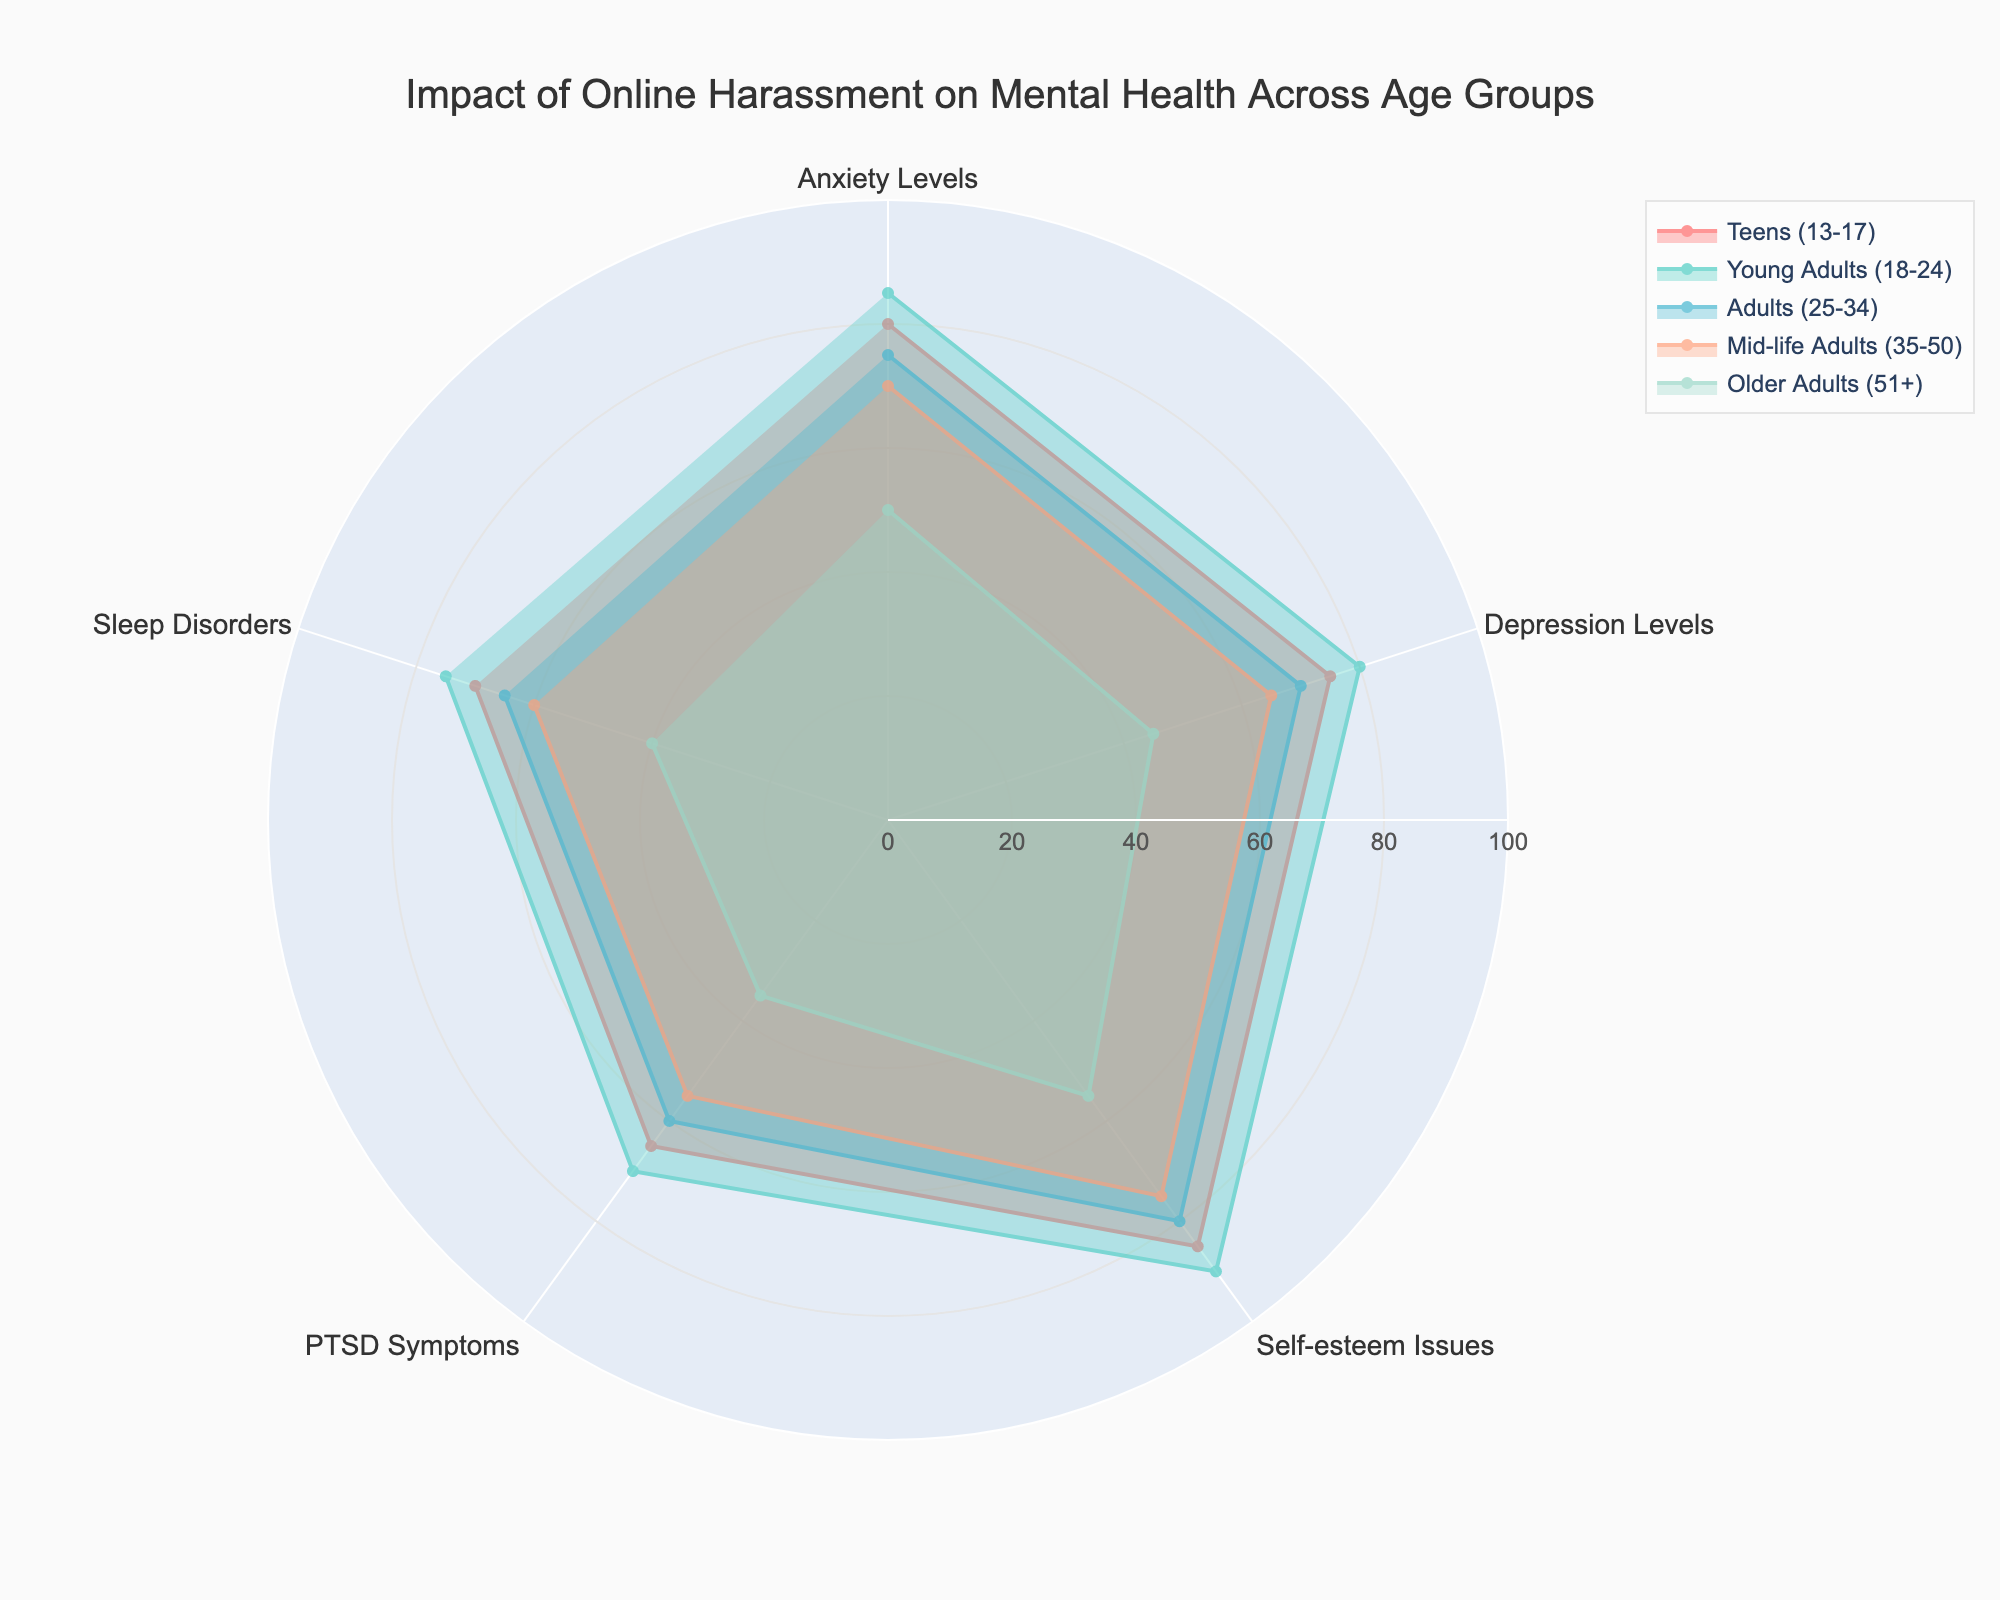What's the title of the radar chart? The title of the chart is displayed at the top and it reads 'Impact of Online Harassment on Mental Health Across Age Groups'.
Answer: Impact of Online Harassment on Mental Health Across Age Groups Which age group has the highest level of anxiety? By examining the 'Anxiety Levels' category, the radar lines for Young Adults (18-24) extend the farthest toward the outer edge of the chart.
Answer: Young Adults (18-24) What is the difference in PTSD symptoms between Teens (13-17) and Older Adults (51+)? Find the values for 'PTSD Symptoms' for Teens (13-17) and Older Adults (51+), which are 65 and 35 respectively. Subtract the latter from the former: 65 - 35 = 30.
Answer: 30 How do the Self-esteem issues levels vary between Adults (25-34) and Mid-life Adults (35-50)? For 'Self-esteem Issues', Adults (25-34) have a value of 80 and Mid-life Adults (35-50) have a value of 75. To compare, subtract Mid-life Adults from Adults: 80 - 75 = 5.
Answer: Adults (25-34) have 5 points higher Which mental health category shows the least variation across age groups? Observing the radar chart, 'PTSD Symptoms' shows the least variation as the lines across the age groups are relatively closer together compared to other categories.
Answer: PTSD Symptoms What's the average level of Depression for the age groups under 35? Average level of 'Depression Levels' for Teens (75), Young Adults (80), and Adults (70). Sum up these values: 75 + 80 + 70 = 225 and divide by 3: 225 / 3 = 75.
Answer: 75 Which age group experiences the lowest level of Sleep Disorders? Observing the 'Sleep Disorders' category, Older Adults (51+) have the lowest level indicated by the smallest extension towards the outer edge.
Answer: Older Adults (51+) Compare the anxiety levels of Young Adults (18-24) and Mid-life Adults (35-50). Which is higher and by how much? Anxiety levels for Young Adults (18-24) is 85 and for Mid-life Adults (35-50) is 70. To compare, subtract the latter from the former: 85 - 70 = 15.
Answer: Young Adults (18-24) by 15 What's the range of Self-esteem Issues for all age groups? The highest value for 'Self-esteem Issues' is 90 (Young Adults 18-24), and the lowest is 55 (Older Adults 51+). Subtract the lowest from the highest: 90 - 55 = 35.
Answer: 35 How do Sleep Disorder levels for Young Adults (18-24) compare to Adults (25-34)? 'Sleep Disorders' value for Young Adults (18-24) is 75 while for Adults (25-34) it's 65. To compare, note the Young Adults have a higher value by: 75 - 65 = 10.
Answer: Young Adults (18-24) are 10 points higher 